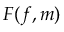<formula> <loc_0><loc_0><loc_500><loc_500>F ( f , m )</formula> 